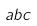<formula> <loc_0><loc_0><loc_500><loc_500>a b c</formula> 